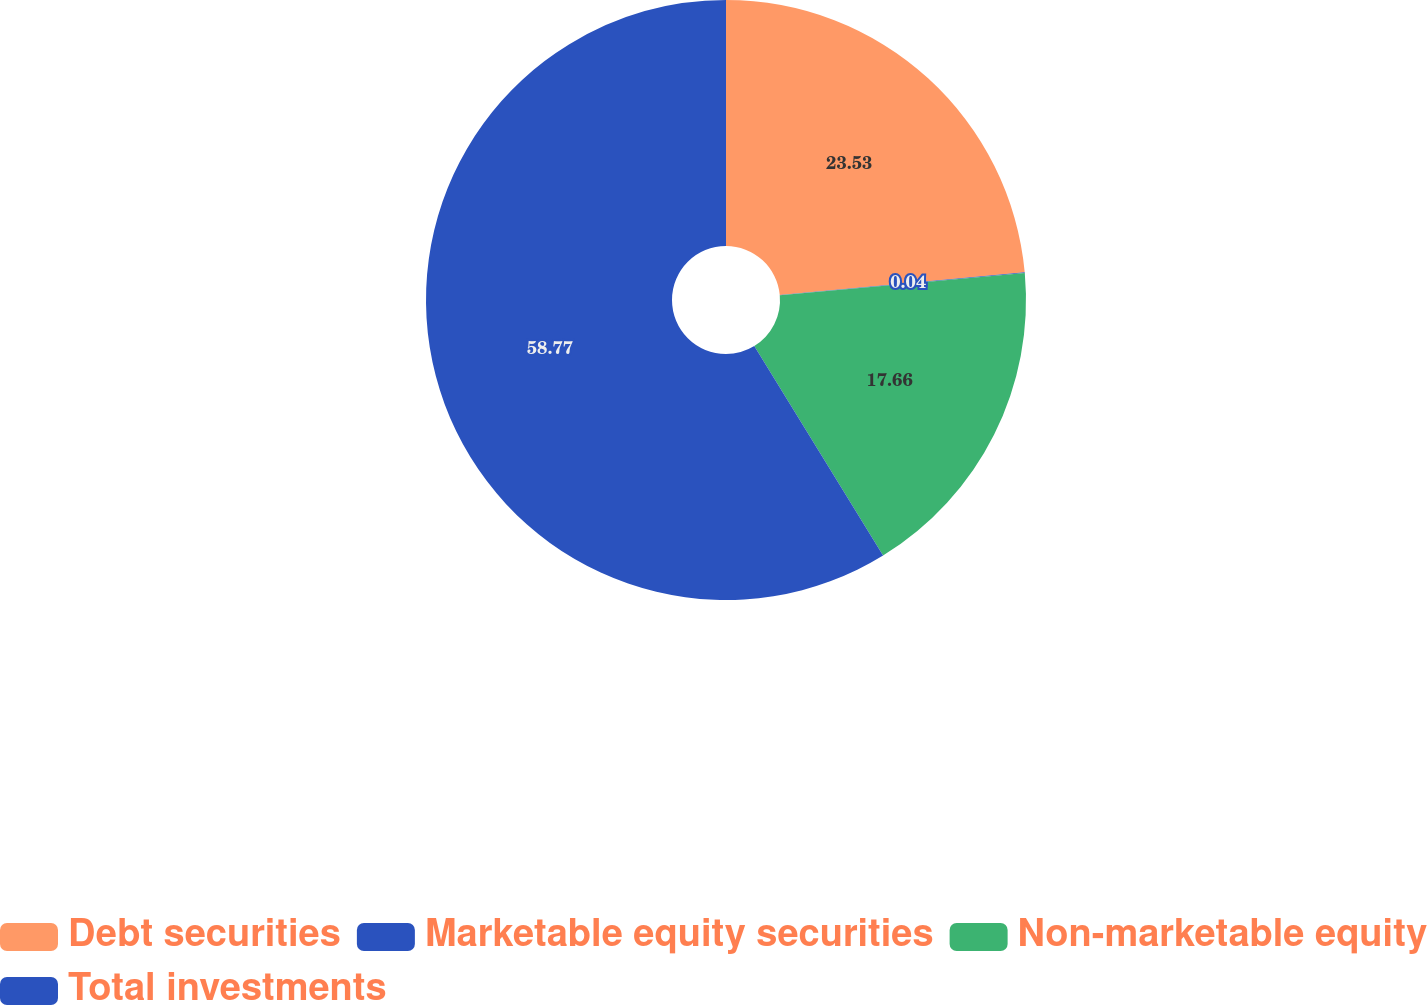Convert chart. <chart><loc_0><loc_0><loc_500><loc_500><pie_chart><fcel>Debt securities<fcel>Marketable equity securities<fcel>Non-marketable equity<fcel>Total investments<nl><fcel>23.53%<fcel>0.04%<fcel>17.66%<fcel>58.77%<nl></chart> 